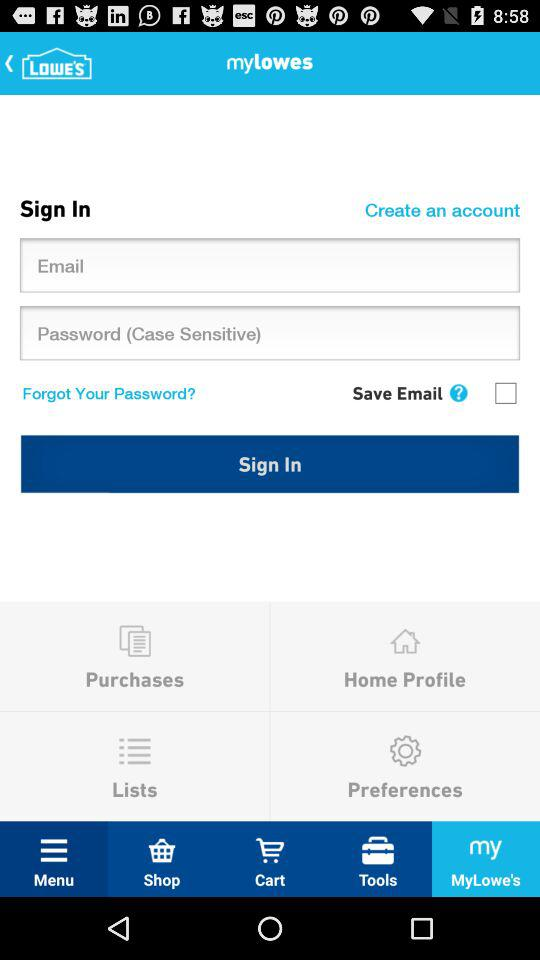What is the status of the "Save Email"? The status is "off". 